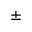<formula> <loc_0><loc_0><loc_500><loc_500>\pm</formula> 